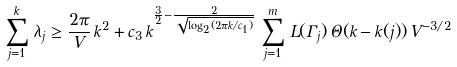<formula> <loc_0><loc_0><loc_500><loc_500>\sum _ { j = 1 } ^ { k } \, \lambda _ { j } & \geq \frac { 2 \pi } { V } \, k ^ { 2 } + c _ { 3 } \, k ^ { \frac { 3 } { 2 } - \frac { 2 } { \sqrt { \log _ { 2 } ( 2 \pi k / c _ { 1 } ) } } } \, \sum _ { j = 1 } ^ { m } \, L ( \Gamma _ { j } ) \, \Theta ( k - k ( j ) ) \, V ^ { - 3 / 2 }</formula> 